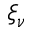<formula> <loc_0><loc_0><loc_500><loc_500>\xi _ { \nu }</formula> 